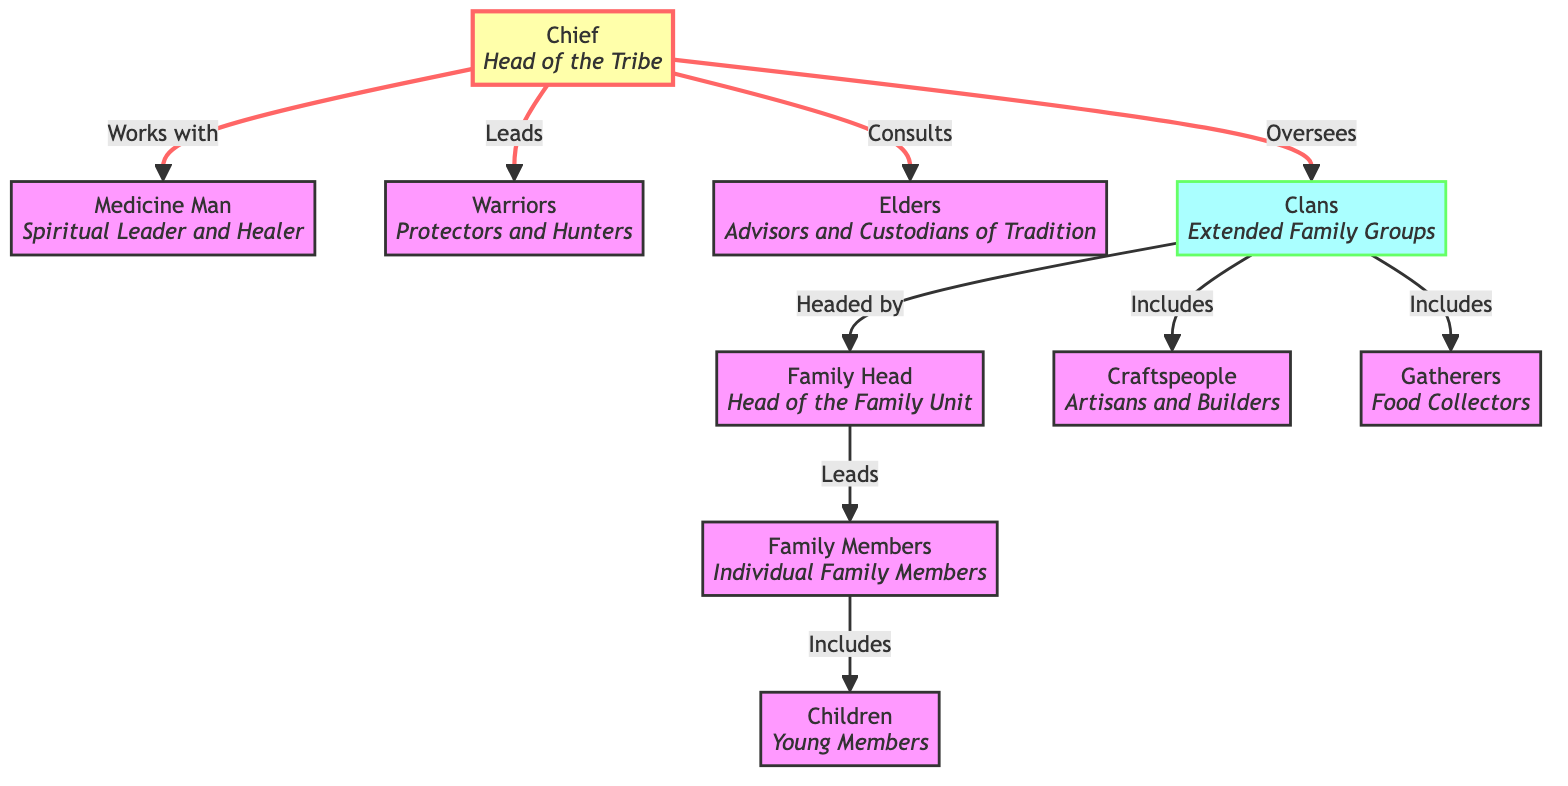What is the role of the Chief? The Chief is described as the head of the tribe, indicating a leadership position with overarching responsibilities.
Answer: Head of the Tribe Who collaborates with the Chief? The diagram shows that the Chief works with the Medicine Man, meaning they have a partnership in the tribe’s leadership.
Answer: Medicine Man How many main societal roles are listed in the diagram? The diagram includes a total of six main roles: Chief, Medicine Man, Warriors, Elders, Clans, and Craftspeople. Counting these nodes gives us the answer.
Answer: Six Who leads the family members? The Family Head is designated as the one who leads the family members, showing their authority within the family unit.
Answer: Family Head Which role is responsible for the protection and hunting of the tribe? The Warriors are identified in the diagram with this specific responsibility, making them vital for protection and sustenance.
Answer: Warriors What are the two roles connected to clans in the diagram? The clans include Craftspeople and Gatherers, indicating these roles are part of extended family groups. Both are illustrated as connected to the clans in the chart.
Answer: Craftspeople and Gatherers What is the hierarchical relationship between the Chief and the Elders? The Chief consults with the Elders, representing a form of advisory relationship where the Chief seeks guidance from those experienced in tradition.
Answer: Consults How are children categorized in relation to family members? Children are included under family members, specifically as the young members of the family unit, indicating their role and connection.
Answer: Young Members Which role is termed as “custodians of tradition”? The Elders are described as advisors and custodians of tradition in the diagram, giving them a protective and instructional role in society.
Answer: Elders 